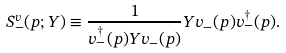Convert formula to latex. <formula><loc_0><loc_0><loc_500><loc_500>S ^ { v } _ { - } ( p ; Y ) \equiv \frac { 1 } { v ^ { \dagger } _ { - } ( p ) Y v _ { - } ( p ) } Y v _ { - } ( p ) v ^ { \dagger } _ { - } ( p ) .</formula> 